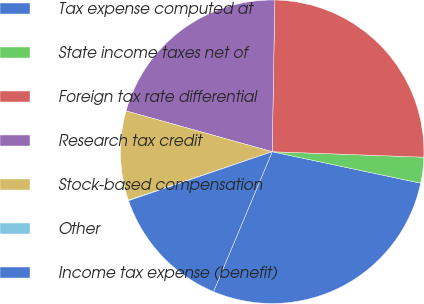Convert chart. <chart><loc_0><loc_0><loc_500><loc_500><pie_chart><fcel>Tax expense computed at<fcel>State income taxes net of<fcel>Foreign tax rate differential<fcel>Research tax credit<fcel>Stock-based compensation<fcel>Other<fcel>Income tax expense (benefit)<nl><fcel>28.0%<fcel>2.75%<fcel>25.3%<fcel>20.94%<fcel>9.51%<fcel>0.05%<fcel>13.45%<nl></chart> 